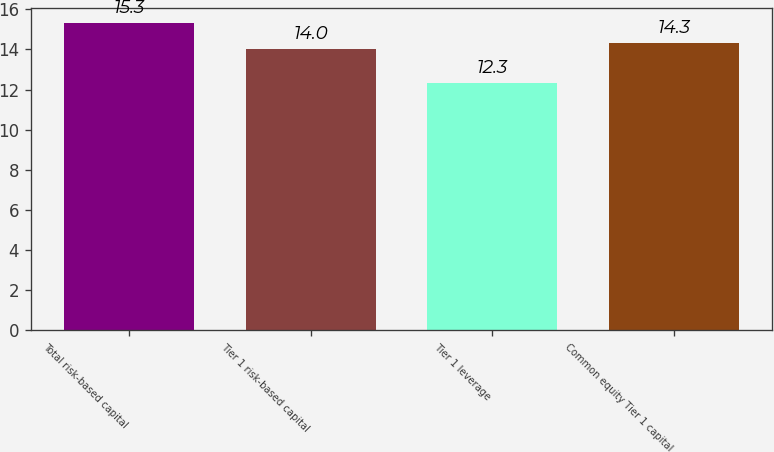<chart> <loc_0><loc_0><loc_500><loc_500><bar_chart><fcel>Total risk-based capital<fcel>Tier 1 risk-based capital<fcel>Tier 1 leverage<fcel>Common equity Tier 1 capital<nl><fcel>15.3<fcel>14<fcel>12.3<fcel>14.3<nl></chart> 